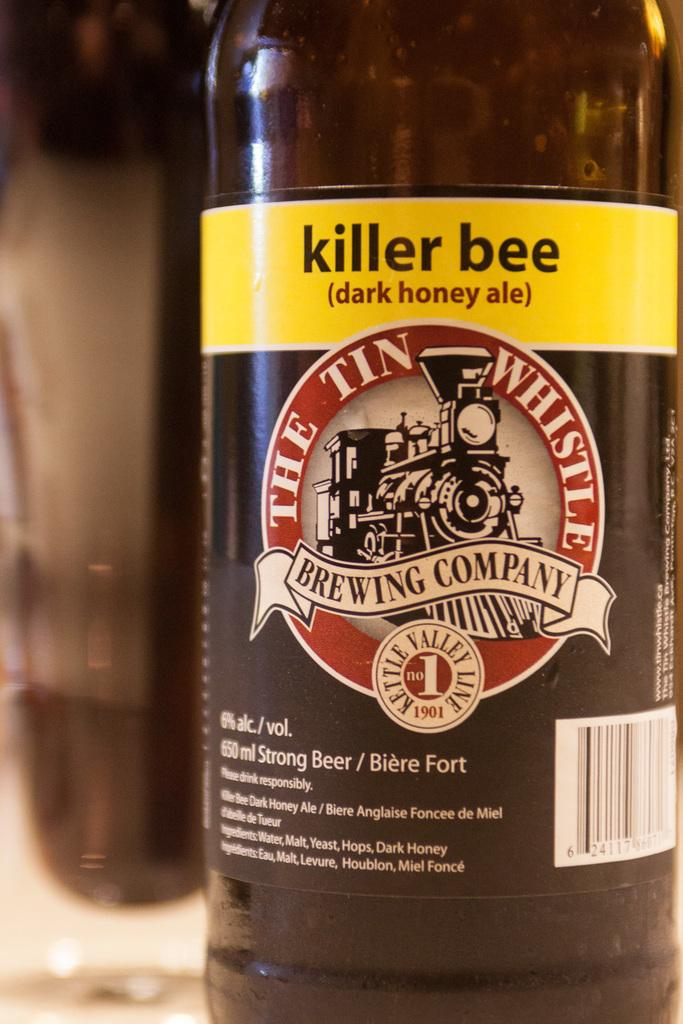<image>
Offer a succinct explanation of the picture presented. A bottle has the logo killer bee on it and a year of 1901. 